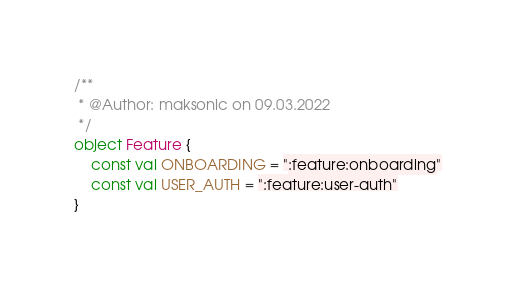Convert code to text. <code><loc_0><loc_0><loc_500><loc_500><_Kotlin_>/**
 * @Author: maksonic on 09.03.2022
 */
object Feature {
    const val ONBOARDING = ":feature:onboarding"
    const val USER_AUTH = ":feature:user-auth"
}</code> 